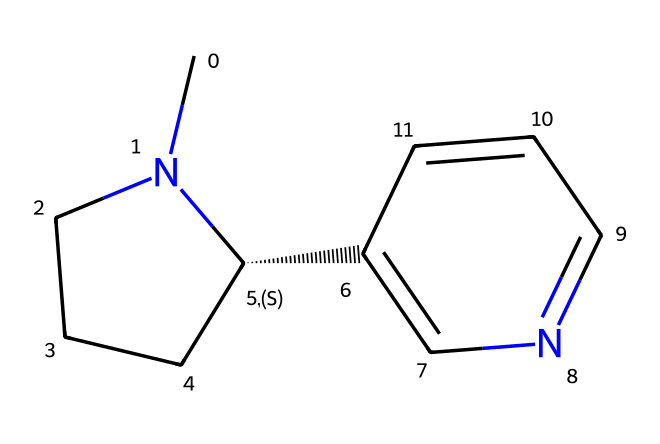What is the molecular formula of nicotine? To derive the molecular formula from the SMILES representation, we identify the atoms present in the structure. The SMILES shows 10 carbon (C) atoms, 14 hydrogen (H) atoms, and 2 nitrogen (N) atoms. Combining these, the molecular formula is C10H14N2.
Answer: C10H14N2 How many nitrogen atoms are present in the structure? By examining the SMILES notation, we notice that there are two nitrogen (N) atoms specified. The presence of "N" indicates the types of atoms in the structure.
Answer: 2 What type of alkaloid is nicotine classified as? Nicotine is classified as a pyridine alkaloid based on its nitrogen-containing six-membered ring system, where the nitrogen atoms contribute to its characteristics and psychoactive effects.
Answer: pyridine What property of nicotine contributes to its stimulant effect? The presence of nitrogen in the ring structure, which acts as a base and interacts with nicotinic acetylcholine receptors in the nervous system, is key to its stimulant properties.
Answer: nitrogen What is the total number of rings in the nicotine structure? Looking at the SMILES structure, nicotine features both a six-membered and a five-membered ring, totaling two rings in the structure.
Answer: 2 Which functional group is responsible for the basicity of nicotine? The amine functional group is responsible for the basicity, which can be determined by the presence of nitrogen atoms that can accept protons (H+).
Answer: amine What role does nicotine play in vintage pinball machine environments? Nicotine, often present in environments where smoking occurs, can create a residue that may impact the aesthetic and functional aspects of vintage machines, leading to alterations in taste and functionality related to the materials used.
Answer: residue 